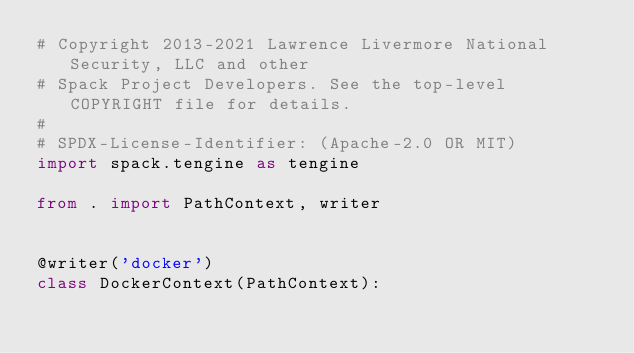<code> <loc_0><loc_0><loc_500><loc_500><_Python_># Copyright 2013-2021 Lawrence Livermore National Security, LLC and other
# Spack Project Developers. See the top-level COPYRIGHT file for details.
#
# SPDX-License-Identifier: (Apache-2.0 OR MIT)
import spack.tengine as tengine

from . import PathContext, writer


@writer('docker')
class DockerContext(PathContext):</code> 